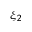<formula> <loc_0><loc_0><loc_500><loc_500>\xi _ { 2 }</formula> 